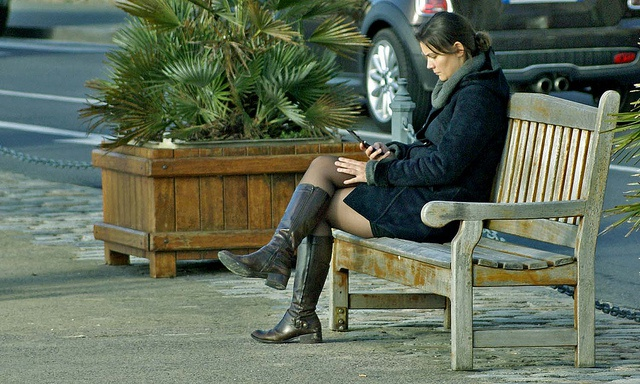Describe the objects in this image and their specific colors. I can see potted plant in black, olive, darkgreen, and gray tones, bench in black, darkgray, gray, and olive tones, people in black, gray, purple, and darkgray tones, car in black, teal, and darkgreen tones, and cell phone in black, gray, teal, and darkgreen tones in this image. 